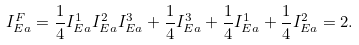<formula> <loc_0><loc_0><loc_500><loc_500>I _ { E a } ^ { F } = \frac { 1 } { 4 } I _ { E a } ^ { 1 } I _ { E a } ^ { 2 } I _ { E a } ^ { 3 } + \frac { 1 } { 4 } I _ { E a } ^ { 3 } + \frac { 1 } { 4 } I _ { E a } ^ { 1 } + \frac { 1 } { 4 } I _ { E a } ^ { 2 } = 2 .</formula> 